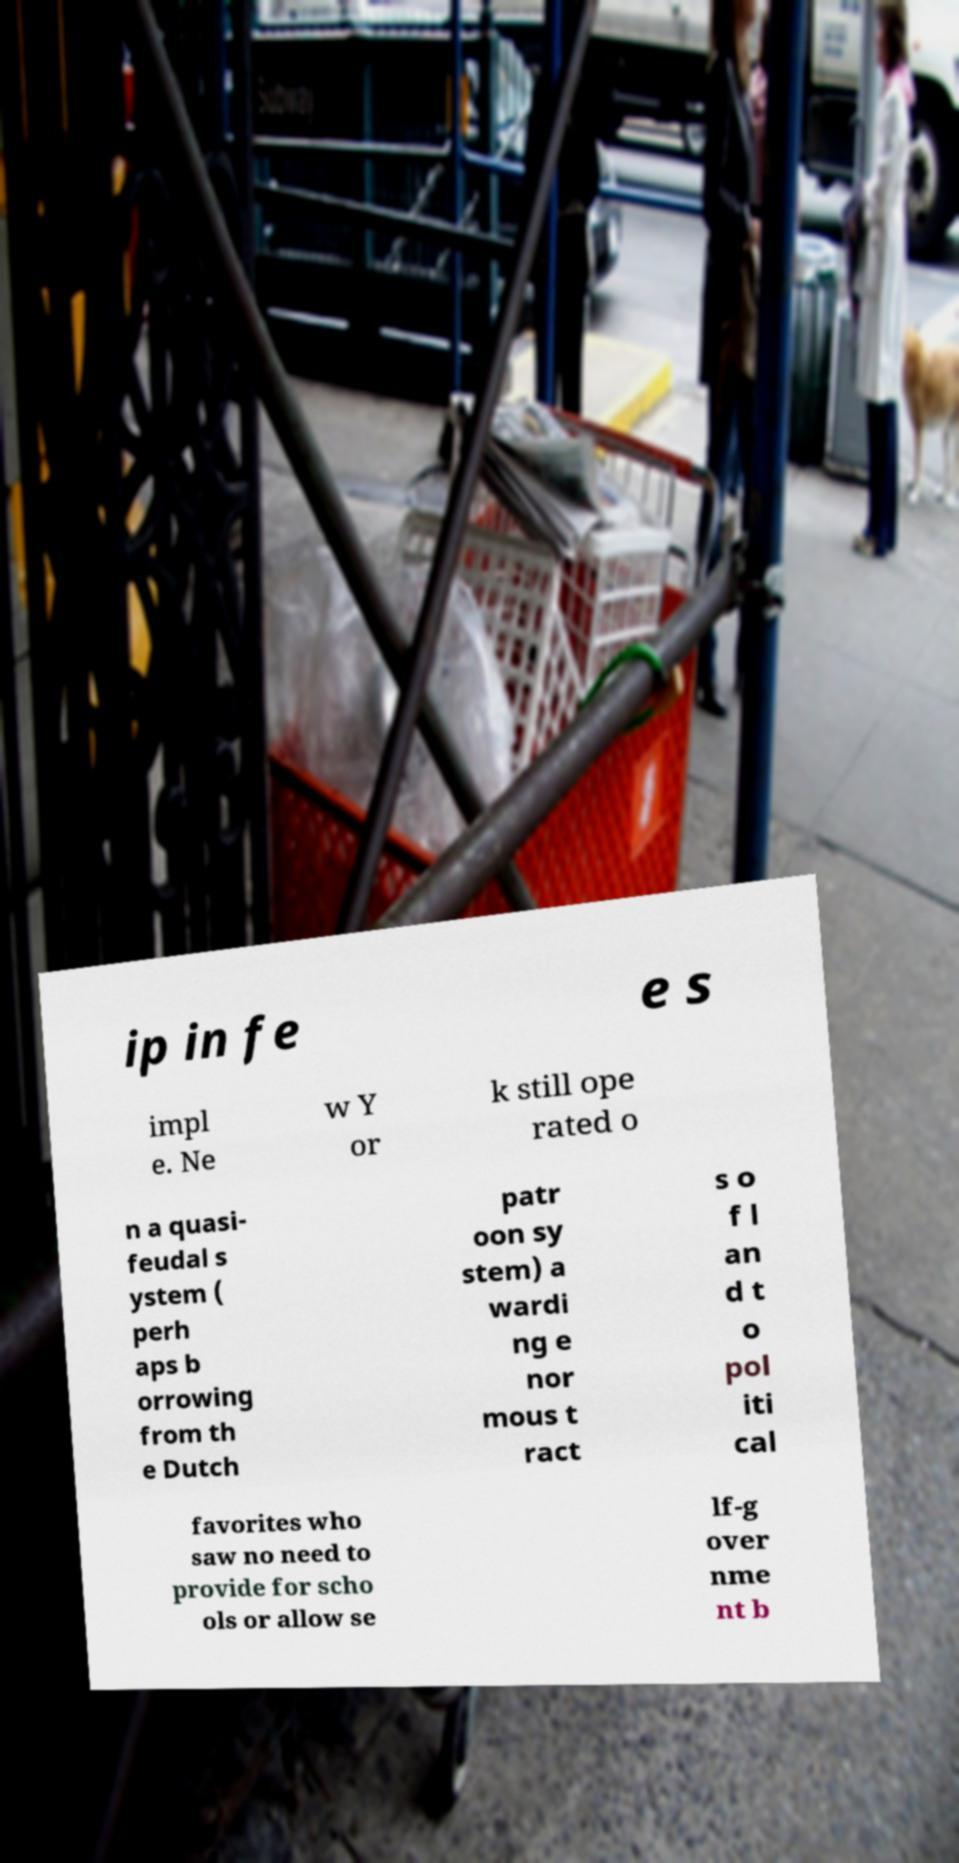Please read and relay the text visible in this image. What does it say? ip in fe e s impl e. Ne w Y or k still ope rated o n a quasi- feudal s ystem ( perh aps b orrowing from th e Dutch patr oon sy stem) a wardi ng e nor mous t ract s o f l an d t o pol iti cal favorites who saw no need to provide for scho ols or allow se lf-g over nme nt b 